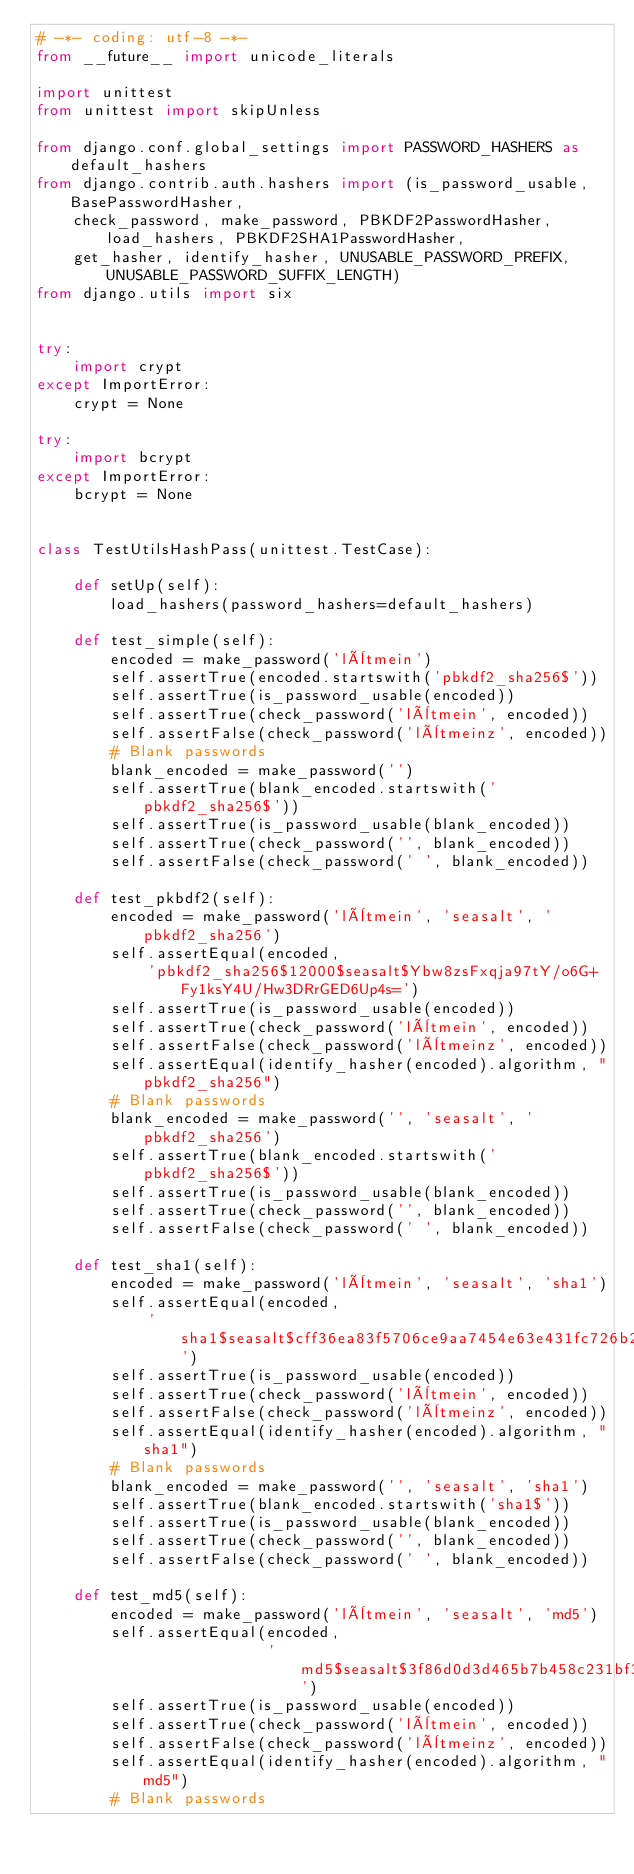Convert code to text. <code><loc_0><loc_0><loc_500><loc_500><_Python_># -*- coding: utf-8 -*-
from __future__ import unicode_literals

import unittest
from unittest import skipUnless

from django.conf.global_settings import PASSWORD_HASHERS as default_hashers
from django.contrib.auth.hashers import (is_password_usable, BasePasswordHasher,
    check_password, make_password, PBKDF2PasswordHasher, load_hashers, PBKDF2SHA1PasswordHasher,
    get_hasher, identify_hasher, UNUSABLE_PASSWORD_PREFIX, UNUSABLE_PASSWORD_SUFFIX_LENGTH)
from django.utils import six


try:
    import crypt
except ImportError:
    crypt = None

try:
    import bcrypt
except ImportError:
    bcrypt = None


class TestUtilsHashPass(unittest.TestCase):

    def setUp(self):
        load_hashers(password_hashers=default_hashers)

    def test_simple(self):
        encoded = make_password('lètmein')
        self.assertTrue(encoded.startswith('pbkdf2_sha256$'))
        self.assertTrue(is_password_usable(encoded))
        self.assertTrue(check_password('lètmein', encoded))
        self.assertFalse(check_password('lètmeinz', encoded))
        # Blank passwords
        blank_encoded = make_password('')
        self.assertTrue(blank_encoded.startswith('pbkdf2_sha256$'))
        self.assertTrue(is_password_usable(blank_encoded))
        self.assertTrue(check_password('', blank_encoded))
        self.assertFalse(check_password(' ', blank_encoded))

    def test_pkbdf2(self):
        encoded = make_password('lètmein', 'seasalt', 'pbkdf2_sha256')
        self.assertEqual(encoded,
            'pbkdf2_sha256$12000$seasalt$Ybw8zsFxqja97tY/o6G+Fy1ksY4U/Hw3DRrGED6Up4s=')
        self.assertTrue(is_password_usable(encoded))
        self.assertTrue(check_password('lètmein', encoded))
        self.assertFalse(check_password('lètmeinz', encoded))
        self.assertEqual(identify_hasher(encoded).algorithm, "pbkdf2_sha256")
        # Blank passwords
        blank_encoded = make_password('', 'seasalt', 'pbkdf2_sha256')
        self.assertTrue(blank_encoded.startswith('pbkdf2_sha256$'))
        self.assertTrue(is_password_usable(blank_encoded))
        self.assertTrue(check_password('', blank_encoded))
        self.assertFalse(check_password(' ', blank_encoded))

    def test_sha1(self):
        encoded = make_password('lètmein', 'seasalt', 'sha1')
        self.assertEqual(encoded,
            'sha1$seasalt$cff36ea83f5706ce9aa7454e63e431fc726b2dc8')
        self.assertTrue(is_password_usable(encoded))
        self.assertTrue(check_password('lètmein', encoded))
        self.assertFalse(check_password('lètmeinz', encoded))
        self.assertEqual(identify_hasher(encoded).algorithm, "sha1")
        # Blank passwords
        blank_encoded = make_password('', 'seasalt', 'sha1')
        self.assertTrue(blank_encoded.startswith('sha1$'))
        self.assertTrue(is_password_usable(blank_encoded))
        self.assertTrue(check_password('', blank_encoded))
        self.assertFalse(check_password(' ', blank_encoded))

    def test_md5(self):
        encoded = make_password('lètmein', 'seasalt', 'md5')
        self.assertEqual(encoded,
                         'md5$seasalt$3f86d0d3d465b7b458c231bf3555c0e3')
        self.assertTrue(is_password_usable(encoded))
        self.assertTrue(check_password('lètmein', encoded))
        self.assertFalse(check_password('lètmeinz', encoded))
        self.assertEqual(identify_hasher(encoded).algorithm, "md5")
        # Blank passwords</code> 